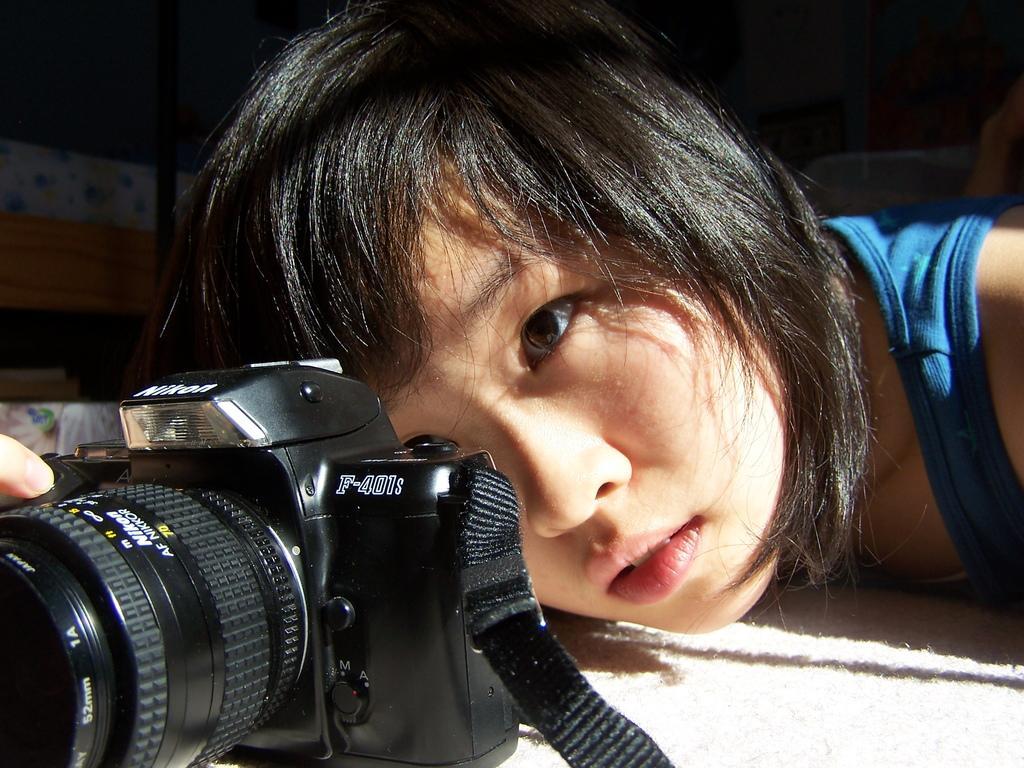Please provide a concise description of this image. As we can see in the image there is a woman holding camera. 